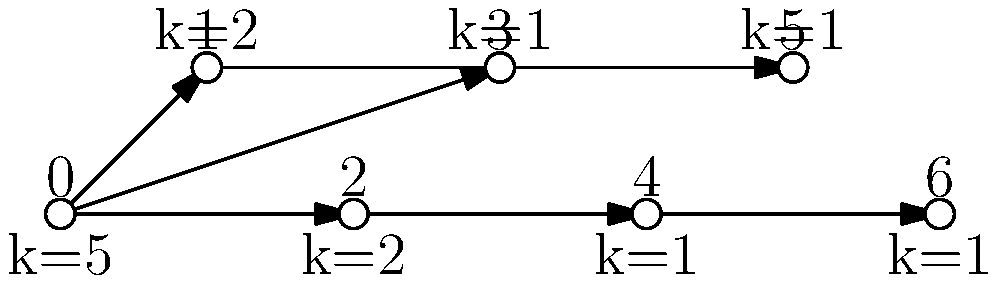In the given scale-free network, what is the probability $P(k)$ of finding a node with degree $k=2$, assuming the network follows a power-law degree distribution with exponent $\gamma=2.5$? To solve this problem, we'll follow these steps:

1) In a scale-free network, the degree distribution follows a power law:

   $$P(k) \propto k^{-\gamma}$$

2) The exact form of the probability is:

   $$P(k) = Ck^{-\gamma}$$

   where $C$ is a normalization constant.

3) We're given that $\gamma = 2.5$.

4) To find $C$, we use the fact that the sum of all probabilities must equal 1:

   $$\sum_{k=1}^{k_{max}} Ck^{-2.5} = 1$$

   where $k_{max}$ is the maximum degree in the network (in this case, 5).

5) Calculating this sum:

   $$C(1^{-2.5} + 2^{-2.5} + 2^{-2.5} + 5^{-2.5}) = 1$$
   $$C(1 + 2(1/2^{2.5}) + 1/5^{2.5}) = 1$$
   $$C \approx 0.7978$$

6) Now we can calculate $P(2)$:

   $$P(2) = 0.7978 * 2^{-2.5} \approx 0.1410$$

Therefore, the probability of finding a node with degree $k=2$ is approximately 0.1410 or 14.10%.
Answer: 0.1410 